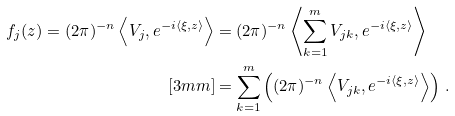<formula> <loc_0><loc_0><loc_500><loc_500>f _ { j } ( z ) = ( 2 \pi ) ^ { - n } \left \langle V _ { j } , e ^ { - i \langle \xi , z \rangle } \right \rangle & = ( 2 \pi ) ^ { - n } \left \langle \sum _ { k = 1 } ^ { m } V _ { j k } , e ^ { - i \langle \xi , z \rangle } \right \rangle \\ [ 3 m m ] & = \sum _ { k = 1 } ^ { m } \left ( ( 2 \pi ) ^ { - n } \left \langle V _ { j k } , e ^ { - i \langle \xi , z \rangle } \right \rangle \right ) \, .</formula> 